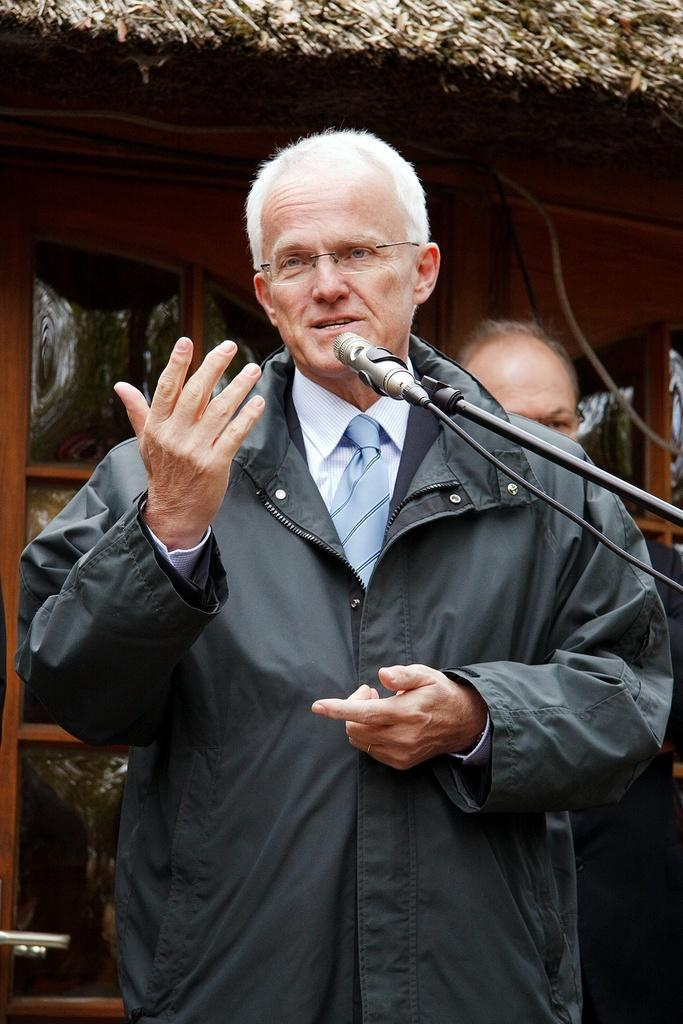What is the person in the image doing? The person is standing in the image and holding a mic. Can you describe the position of the second person in the image? The second person is standing behind the first person. What can be seen in the background of the image? There is a house in the background of the image. What type of toys can be seen in the hands of the family members in the image? There is no mention of toys or family members in the image; it only features two people and a house in the background. 